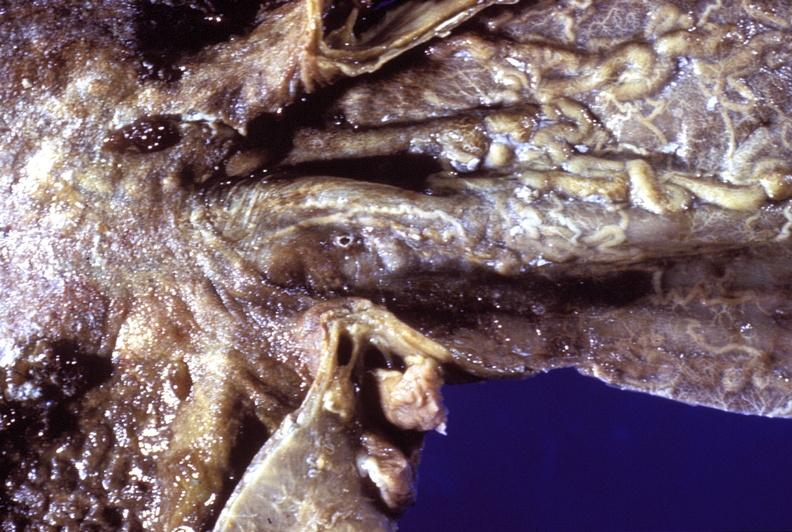what does this image show?
Answer the question using a single word or phrase. Esophagus 